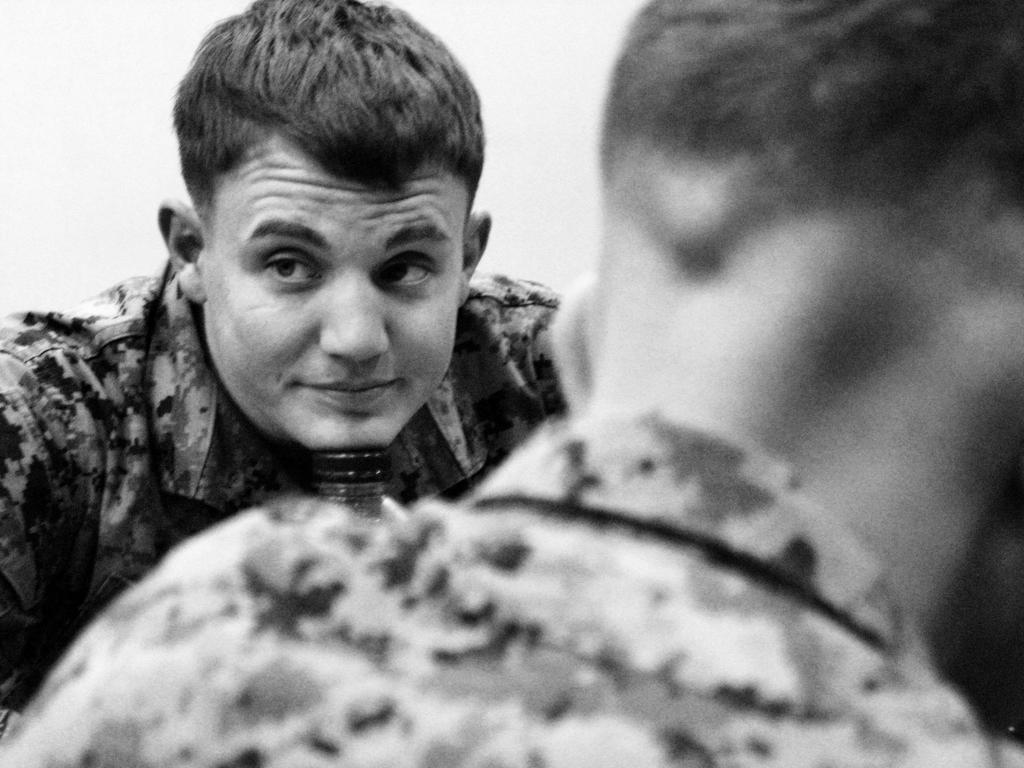Who is present in the image? There is a man in the image, and there is another person in the foreground. Can you describe the man in the image? Unfortunately, the facts provided do not give any details about the man's appearance or clothing. What is the relationship between the man and the other person in the foreground? The facts provided do not give any information about their relationship or interaction. How does the jellyfish affect the man in the image? There is no jellyfish present in the image, so it cannot affect the man. 